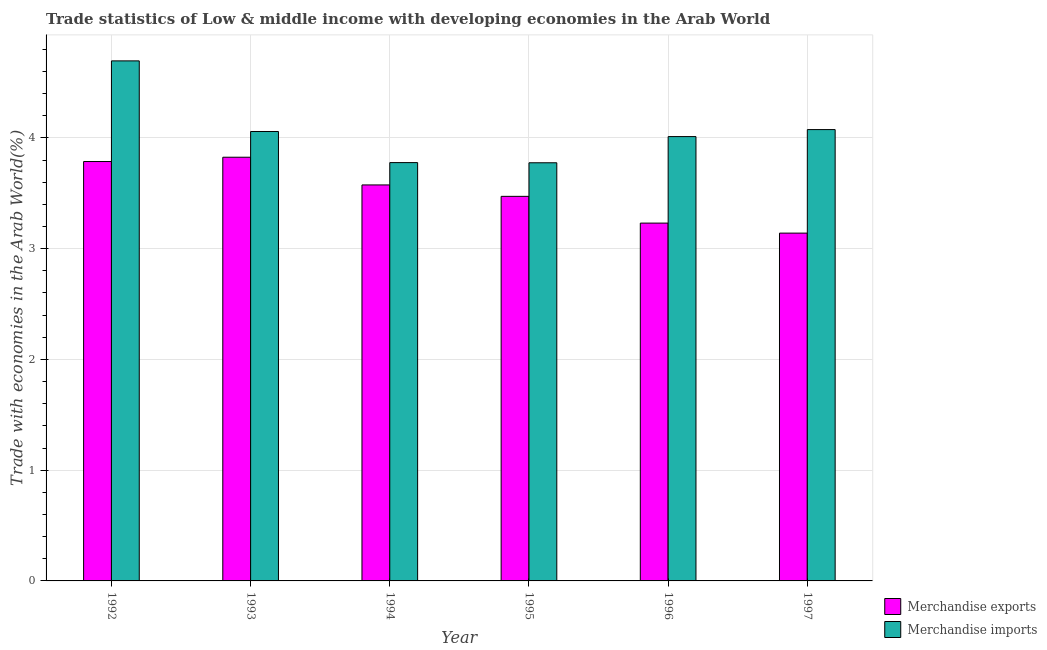How many different coloured bars are there?
Your answer should be very brief. 2. How many bars are there on the 1st tick from the right?
Your answer should be very brief. 2. In how many cases, is the number of bars for a given year not equal to the number of legend labels?
Ensure brevity in your answer.  0. What is the merchandise exports in 1994?
Provide a succinct answer. 3.58. Across all years, what is the maximum merchandise exports?
Keep it short and to the point. 3.83. Across all years, what is the minimum merchandise exports?
Your response must be concise. 3.14. What is the total merchandise imports in the graph?
Provide a short and direct response. 24.39. What is the difference between the merchandise exports in 1994 and that in 1996?
Offer a very short reply. 0.34. What is the difference between the merchandise imports in 1994 and the merchandise exports in 1993?
Provide a short and direct response. -0.28. What is the average merchandise exports per year?
Offer a terse response. 3.51. What is the ratio of the merchandise imports in 1993 to that in 1994?
Your answer should be very brief. 1.07. What is the difference between the highest and the second highest merchandise imports?
Keep it short and to the point. 0.62. What is the difference between the highest and the lowest merchandise imports?
Offer a very short reply. 0.92. In how many years, is the merchandise imports greater than the average merchandise imports taken over all years?
Your answer should be very brief. 2. What does the 1st bar from the left in 1995 represents?
Keep it short and to the point. Merchandise exports. What does the 2nd bar from the right in 1992 represents?
Keep it short and to the point. Merchandise exports. How many years are there in the graph?
Offer a terse response. 6. What is the difference between two consecutive major ticks on the Y-axis?
Give a very brief answer. 1. Does the graph contain any zero values?
Provide a succinct answer. No. Does the graph contain grids?
Give a very brief answer. Yes. How are the legend labels stacked?
Make the answer very short. Vertical. What is the title of the graph?
Your response must be concise. Trade statistics of Low & middle income with developing economies in the Arab World. What is the label or title of the Y-axis?
Your answer should be compact. Trade with economies in the Arab World(%). What is the Trade with economies in the Arab World(%) in Merchandise exports in 1992?
Provide a short and direct response. 3.79. What is the Trade with economies in the Arab World(%) of Merchandise imports in 1992?
Keep it short and to the point. 4.7. What is the Trade with economies in the Arab World(%) of Merchandise exports in 1993?
Provide a succinct answer. 3.83. What is the Trade with economies in the Arab World(%) in Merchandise imports in 1993?
Give a very brief answer. 4.06. What is the Trade with economies in the Arab World(%) of Merchandise exports in 1994?
Provide a short and direct response. 3.58. What is the Trade with economies in the Arab World(%) of Merchandise imports in 1994?
Provide a short and direct response. 3.78. What is the Trade with economies in the Arab World(%) of Merchandise exports in 1995?
Your answer should be very brief. 3.47. What is the Trade with economies in the Arab World(%) in Merchandise imports in 1995?
Ensure brevity in your answer.  3.78. What is the Trade with economies in the Arab World(%) in Merchandise exports in 1996?
Make the answer very short. 3.23. What is the Trade with economies in the Arab World(%) in Merchandise imports in 1996?
Offer a very short reply. 4.01. What is the Trade with economies in the Arab World(%) of Merchandise exports in 1997?
Give a very brief answer. 3.14. What is the Trade with economies in the Arab World(%) in Merchandise imports in 1997?
Your answer should be very brief. 4.07. Across all years, what is the maximum Trade with economies in the Arab World(%) of Merchandise exports?
Keep it short and to the point. 3.83. Across all years, what is the maximum Trade with economies in the Arab World(%) in Merchandise imports?
Make the answer very short. 4.7. Across all years, what is the minimum Trade with economies in the Arab World(%) of Merchandise exports?
Give a very brief answer. 3.14. Across all years, what is the minimum Trade with economies in the Arab World(%) in Merchandise imports?
Make the answer very short. 3.78. What is the total Trade with economies in the Arab World(%) of Merchandise exports in the graph?
Give a very brief answer. 21.03. What is the total Trade with economies in the Arab World(%) in Merchandise imports in the graph?
Keep it short and to the point. 24.39. What is the difference between the Trade with economies in the Arab World(%) in Merchandise exports in 1992 and that in 1993?
Offer a very short reply. -0.04. What is the difference between the Trade with economies in the Arab World(%) in Merchandise imports in 1992 and that in 1993?
Offer a very short reply. 0.64. What is the difference between the Trade with economies in the Arab World(%) of Merchandise exports in 1992 and that in 1994?
Keep it short and to the point. 0.21. What is the difference between the Trade with economies in the Arab World(%) in Merchandise imports in 1992 and that in 1994?
Make the answer very short. 0.92. What is the difference between the Trade with economies in the Arab World(%) of Merchandise exports in 1992 and that in 1995?
Give a very brief answer. 0.31. What is the difference between the Trade with economies in the Arab World(%) in Merchandise exports in 1992 and that in 1996?
Offer a terse response. 0.56. What is the difference between the Trade with economies in the Arab World(%) in Merchandise imports in 1992 and that in 1996?
Give a very brief answer. 0.68. What is the difference between the Trade with economies in the Arab World(%) in Merchandise exports in 1992 and that in 1997?
Your answer should be compact. 0.65. What is the difference between the Trade with economies in the Arab World(%) of Merchandise imports in 1992 and that in 1997?
Offer a very short reply. 0.62. What is the difference between the Trade with economies in the Arab World(%) of Merchandise exports in 1993 and that in 1994?
Give a very brief answer. 0.25. What is the difference between the Trade with economies in the Arab World(%) in Merchandise imports in 1993 and that in 1994?
Give a very brief answer. 0.28. What is the difference between the Trade with economies in the Arab World(%) of Merchandise exports in 1993 and that in 1995?
Offer a terse response. 0.35. What is the difference between the Trade with economies in the Arab World(%) of Merchandise imports in 1993 and that in 1995?
Your response must be concise. 0.28. What is the difference between the Trade with economies in the Arab World(%) of Merchandise exports in 1993 and that in 1996?
Offer a very short reply. 0.59. What is the difference between the Trade with economies in the Arab World(%) in Merchandise imports in 1993 and that in 1996?
Offer a terse response. 0.05. What is the difference between the Trade with economies in the Arab World(%) in Merchandise exports in 1993 and that in 1997?
Keep it short and to the point. 0.69. What is the difference between the Trade with economies in the Arab World(%) in Merchandise imports in 1993 and that in 1997?
Your response must be concise. -0.02. What is the difference between the Trade with economies in the Arab World(%) in Merchandise exports in 1994 and that in 1995?
Your answer should be compact. 0.1. What is the difference between the Trade with economies in the Arab World(%) of Merchandise imports in 1994 and that in 1995?
Your response must be concise. 0. What is the difference between the Trade with economies in the Arab World(%) of Merchandise exports in 1994 and that in 1996?
Your response must be concise. 0.34. What is the difference between the Trade with economies in the Arab World(%) of Merchandise imports in 1994 and that in 1996?
Ensure brevity in your answer.  -0.23. What is the difference between the Trade with economies in the Arab World(%) in Merchandise exports in 1994 and that in 1997?
Your answer should be very brief. 0.43. What is the difference between the Trade with economies in the Arab World(%) in Merchandise imports in 1994 and that in 1997?
Your answer should be compact. -0.3. What is the difference between the Trade with economies in the Arab World(%) of Merchandise exports in 1995 and that in 1996?
Your answer should be very brief. 0.24. What is the difference between the Trade with economies in the Arab World(%) of Merchandise imports in 1995 and that in 1996?
Keep it short and to the point. -0.24. What is the difference between the Trade with economies in the Arab World(%) of Merchandise exports in 1995 and that in 1997?
Your answer should be compact. 0.33. What is the difference between the Trade with economies in the Arab World(%) in Merchandise imports in 1995 and that in 1997?
Ensure brevity in your answer.  -0.3. What is the difference between the Trade with economies in the Arab World(%) of Merchandise exports in 1996 and that in 1997?
Offer a terse response. 0.09. What is the difference between the Trade with economies in the Arab World(%) in Merchandise imports in 1996 and that in 1997?
Your answer should be compact. -0.06. What is the difference between the Trade with economies in the Arab World(%) in Merchandise exports in 1992 and the Trade with economies in the Arab World(%) in Merchandise imports in 1993?
Ensure brevity in your answer.  -0.27. What is the difference between the Trade with economies in the Arab World(%) in Merchandise exports in 1992 and the Trade with economies in the Arab World(%) in Merchandise imports in 1994?
Your response must be concise. 0.01. What is the difference between the Trade with economies in the Arab World(%) of Merchandise exports in 1992 and the Trade with economies in the Arab World(%) of Merchandise imports in 1995?
Make the answer very short. 0.01. What is the difference between the Trade with economies in the Arab World(%) of Merchandise exports in 1992 and the Trade with economies in the Arab World(%) of Merchandise imports in 1996?
Your response must be concise. -0.23. What is the difference between the Trade with economies in the Arab World(%) of Merchandise exports in 1992 and the Trade with economies in the Arab World(%) of Merchandise imports in 1997?
Offer a terse response. -0.29. What is the difference between the Trade with economies in the Arab World(%) of Merchandise exports in 1993 and the Trade with economies in the Arab World(%) of Merchandise imports in 1994?
Offer a very short reply. 0.05. What is the difference between the Trade with economies in the Arab World(%) in Merchandise exports in 1993 and the Trade with economies in the Arab World(%) in Merchandise imports in 1995?
Provide a succinct answer. 0.05. What is the difference between the Trade with economies in the Arab World(%) of Merchandise exports in 1993 and the Trade with economies in the Arab World(%) of Merchandise imports in 1996?
Offer a very short reply. -0.19. What is the difference between the Trade with economies in the Arab World(%) of Merchandise exports in 1993 and the Trade with economies in the Arab World(%) of Merchandise imports in 1997?
Ensure brevity in your answer.  -0.25. What is the difference between the Trade with economies in the Arab World(%) in Merchandise exports in 1994 and the Trade with economies in the Arab World(%) in Merchandise imports in 1996?
Provide a short and direct response. -0.44. What is the difference between the Trade with economies in the Arab World(%) of Merchandise exports in 1994 and the Trade with economies in the Arab World(%) of Merchandise imports in 1997?
Make the answer very short. -0.5. What is the difference between the Trade with economies in the Arab World(%) of Merchandise exports in 1995 and the Trade with economies in the Arab World(%) of Merchandise imports in 1996?
Offer a very short reply. -0.54. What is the difference between the Trade with economies in the Arab World(%) of Merchandise exports in 1995 and the Trade with economies in the Arab World(%) of Merchandise imports in 1997?
Your response must be concise. -0.6. What is the difference between the Trade with economies in the Arab World(%) of Merchandise exports in 1996 and the Trade with economies in the Arab World(%) of Merchandise imports in 1997?
Your answer should be compact. -0.84. What is the average Trade with economies in the Arab World(%) of Merchandise exports per year?
Offer a very short reply. 3.5. What is the average Trade with economies in the Arab World(%) in Merchandise imports per year?
Provide a short and direct response. 4.07. In the year 1992, what is the difference between the Trade with economies in the Arab World(%) in Merchandise exports and Trade with economies in the Arab World(%) in Merchandise imports?
Provide a short and direct response. -0.91. In the year 1993, what is the difference between the Trade with economies in the Arab World(%) in Merchandise exports and Trade with economies in the Arab World(%) in Merchandise imports?
Your answer should be very brief. -0.23. In the year 1994, what is the difference between the Trade with economies in the Arab World(%) in Merchandise exports and Trade with economies in the Arab World(%) in Merchandise imports?
Provide a short and direct response. -0.2. In the year 1995, what is the difference between the Trade with economies in the Arab World(%) of Merchandise exports and Trade with economies in the Arab World(%) of Merchandise imports?
Your response must be concise. -0.3. In the year 1996, what is the difference between the Trade with economies in the Arab World(%) in Merchandise exports and Trade with economies in the Arab World(%) in Merchandise imports?
Make the answer very short. -0.78. In the year 1997, what is the difference between the Trade with economies in the Arab World(%) of Merchandise exports and Trade with economies in the Arab World(%) of Merchandise imports?
Provide a short and direct response. -0.93. What is the ratio of the Trade with economies in the Arab World(%) of Merchandise imports in 1992 to that in 1993?
Make the answer very short. 1.16. What is the ratio of the Trade with economies in the Arab World(%) of Merchandise exports in 1992 to that in 1994?
Keep it short and to the point. 1.06. What is the ratio of the Trade with economies in the Arab World(%) of Merchandise imports in 1992 to that in 1994?
Make the answer very short. 1.24. What is the ratio of the Trade with economies in the Arab World(%) of Merchandise exports in 1992 to that in 1995?
Provide a succinct answer. 1.09. What is the ratio of the Trade with economies in the Arab World(%) of Merchandise imports in 1992 to that in 1995?
Keep it short and to the point. 1.24. What is the ratio of the Trade with economies in the Arab World(%) in Merchandise exports in 1992 to that in 1996?
Keep it short and to the point. 1.17. What is the ratio of the Trade with economies in the Arab World(%) in Merchandise imports in 1992 to that in 1996?
Your answer should be compact. 1.17. What is the ratio of the Trade with economies in the Arab World(%) of Merchandise exports in 1992 to that in 1997?
Your response must be concise. 1.21. What is the ratio of the Trade with economies in the Arab World(%) of Merchandise imports in 1992 to that in 1997?
Provide a succinct answer. 1.15. What is the ratio of the Trade with economies in the Arab World(%) in Merchandise exports in 1993 to that in 1994?
Give a very brief answer. 1.07. What is the ratio of the Trade with economies in the Arab World(%) in Merchandise imports in 1993 to that in 1994?
Offer a very short reply. 1.07. What is the ratio of the Trade with economies in the Arab World(%) in Merchandise exports in 1993 to that in 1995?
Your answer should be very brief. 1.1. What is the ratio of the Trade with economies in the Arab World(%) of Merchandise imports in 1993 to that in 1995?
Ensure brevity in your answer.  1.07. What is the ratio of the Trade with economies in the Arab World(%) of Merchandise exports in 1993 to that in 1996?
Offer a terse response. 1.18. What is the ratio of the Trade with economies in the Arab World(%) in Merchandise imports in 1993 to that in 1996?
Your response must be concise. 1.01. What is the ratio of the Trade with economies in the Arab World(%) in Merchandise exports in 1993 to that in 1997?
Your answer should be very brief. 1.22. What is the ratio of the Trade with economies in the Arab World(%) in Merchandise imports in 1993 to that in 1997?
Your answer should be compact. 1. What is the ratio of the Trade with economies in the Arab World(%) of Merchandise exports in 1994 to that in 1995?
Your response must be concise. 1.03. What is the ratio of the Trade with economies in the Arab World(%) in Merchandise exports in 1994 to that in 1996?
Give a very brief answer. 1.11. What is the ratio of the Trade with economies in the Arab World(%) of Merchandise imports in 1994 to that in 1996?
Keep it short and to the point. 0.94. What is the ratio of the Trade with economies in the Arab World(%) in Merchandise exports in 1994 to that in 1997?
Your response must be concise. 1.14. What is the ratio of the Trade with economies in the Arab World(%) in Merchandise imports in 1994 to that in 1997?
Offer a terse response. 0.93. What is the ratio of the Trade with economies in the Arab World(%) in Merchandise exports in 1995 to that in 1996?
Provide a short and direct response. 1.07. What is the ratio of the Trade with economies in the Arab World(%) in Merchandise imports in 1995 to that in 1996?
Offer a very short reply. 0.94. What is the ratio of the Trade with economies in the Arab World(%) in Merchandise exports in 1995 to that in 1997?
Make the answer very short. 1.11. What is the ratio of the Trade with economies in the Arab World(%) of Merchandise imports in 1995 to that in 1997?
Provide a succinct answer. 0.93. What is the ratio of the Trade with economies in the Arab World(%) in Merchandise exports in 1996 to that in 1997?
Your answer should be compact. 1.03. What is the ratio of the Trade with economies in the Arab World(%) of Merchandise imports in 1996 to that in 1997?
Your answer should be very brief. 0.98. What is the difference between the highest and the second highest Trade with economies in the Arab World(%) in Merchandise exports?
Make the answer very short. 0.04. What is the difference between the highest and the second highest Trade with economies in the Arab World(%) of Merchandise imports?
Ensure brevity in your answer.  0.62. What is the difference between the highest and the lowest Trade with economies in the Arab World(%) in Merchandise exports?
Your response must be concise. 0.69. 